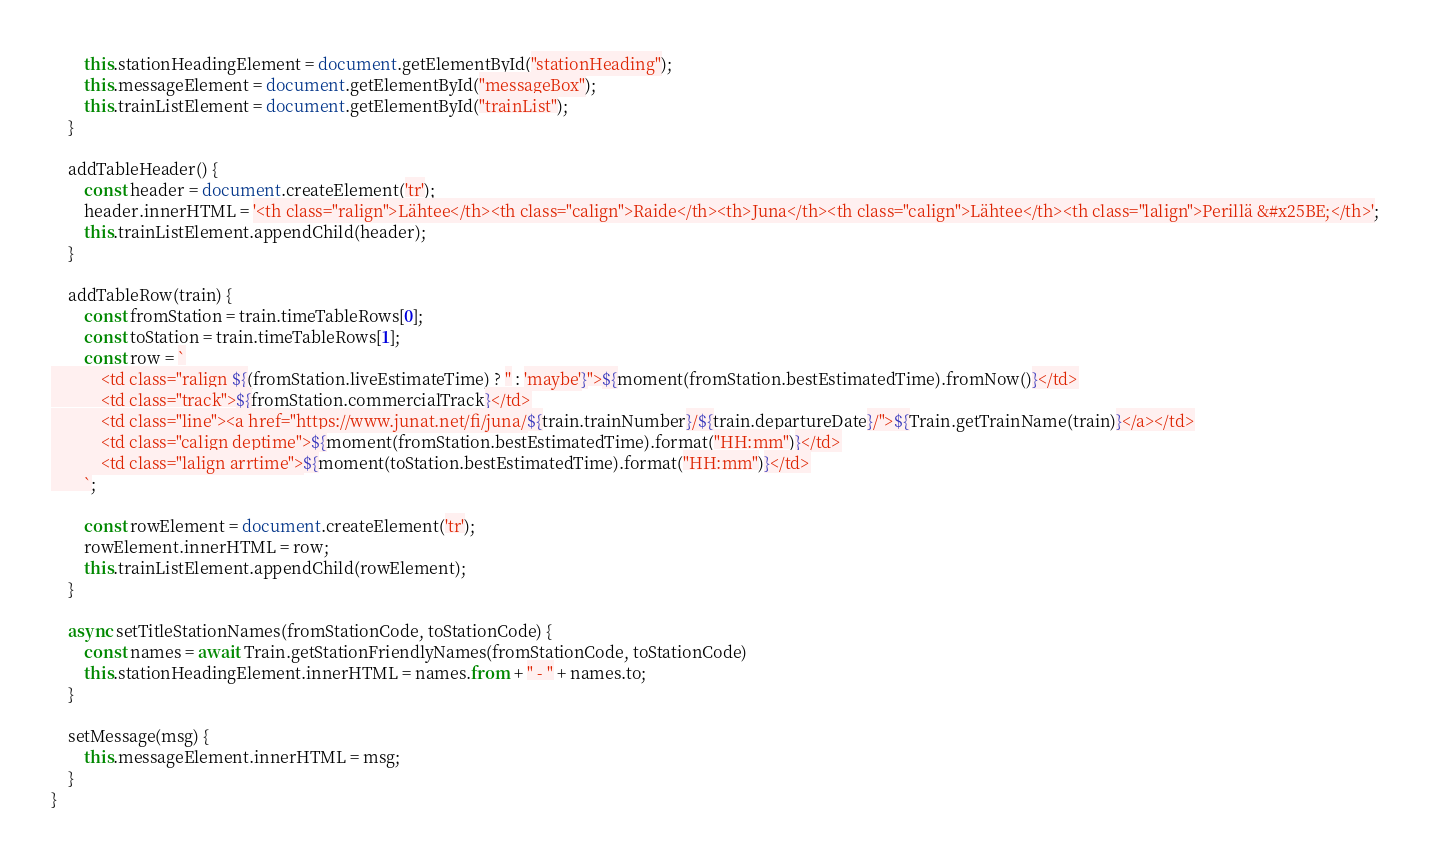Convert code to text. <code><loc_0><loc_0><loc_500><loc_500><_JavaScript_>        this.stationHeadingElement = document.getElementById("stationHeading");
        this.messageElement = document.getElementById("messageBox");
        this.trainListElement = document.getElementById("trainList");
    }

    addTableHeader() {
        const header = document.createElement('tr');
        header.innerHTML = '<th class="ralign">Lähtee</th><th class="calign">Raide</th><th>Juna</th><th class="calign">Lähtee</th><th class="lalign">Perillä &#x25BE;</th>';
        this.trainListElement.appendChild(header);
    }

    addTableRow(train) {
        const fromStation = train.timeTableRows[0];
        const toStation = train.timeTableRows[1];
        const row = `
            <td class="ralign ${(fromStation.liveEstimateTime) ? '' : 'maybe'}">${moment(fromStation.bestEstimatedTime).fromNow()}</td>
            <td class="track">${fromStation.commercialTrack}</td>
            <td class="line"><a href="https://www.junat.net/fi/juna/${train.trainNumber}/${train.departureDate}/">${Train.getTrainName(train)}</a></td>
            <td class="calign deptime">${moment(fromStation.bestEstimatedTime).format("HH:mm")}</td>
            <td class="lalign arrtime">${moment(toStation.bestEstimatedTime).format("HH:mm")}</td>
        `;

        const rowElement = document.createElement('tr');
        rowElement.innerHTML = row;
        this.trainListElement.appendChild(rowElement);
    }

    async setTitleStationNames(fromStationCode, toStationCode) {
        const names = await Train.getStationFriendlyNames(fromStationCode, toStationCode)
        this.stationHeadingElement.innerHTML = names.from + " - " + names.to;
    }

    setMessage(msg) {
        this.messageElement.innerHTML = msg;
    }
}
</code> 